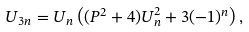<formula> <loc_0><loc_0><loc_500><loc_500>U _ { 3 n } = U _ { n } \left ( ( P ^ { 2 } + 4 ) U _ { n } ^ { 2 } + 3 ( - 1 ) ^ { n } \right ) ,</formula> 